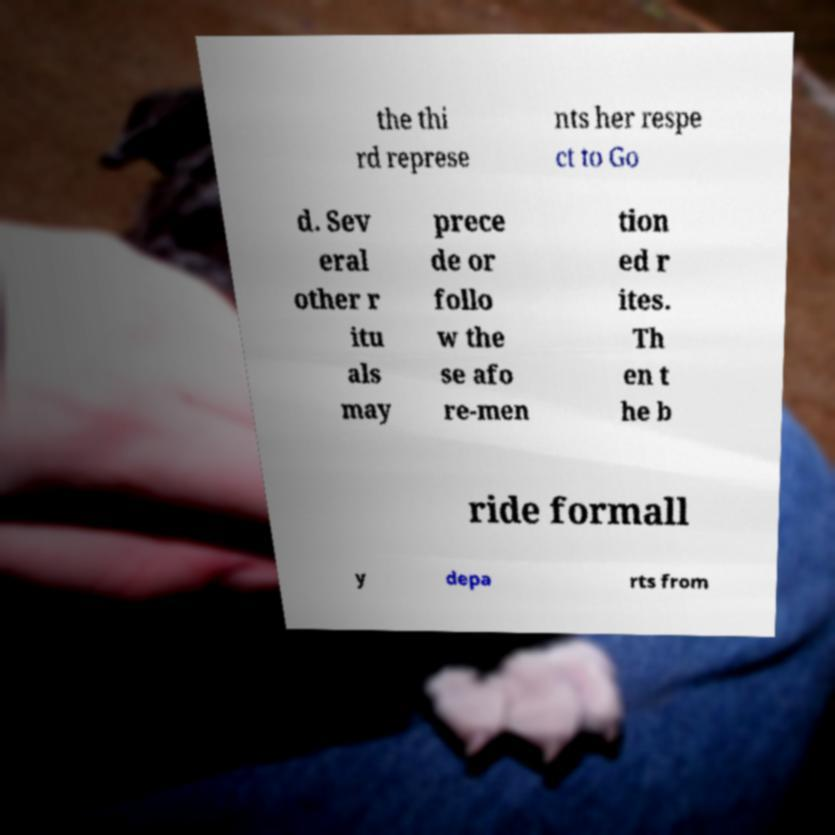There's text embedded in this image that I need extracted. Can you transcribe it verbatim? the thi rd represe nts her respe ct to Go d. Sev eral other r itu als may prece de or follo w the se afo re-men tion ed r ites. Th en t he b ride formall y depa rts from 